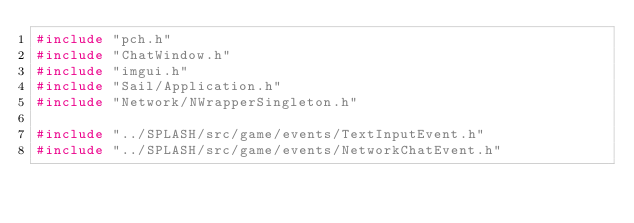Convert code to text. <code><loc_0><loc_0><loc_500><loc_500><_C++_>#include "pch.h"
#include "ChatWindow.h"
#include "imgui.h"
#include "Sail/Application.h"
#include "Network/NWrapperSingleton.h"

#include "../SPLASH/src/game/events/TextInputEvent.h"
#include "../SPLASH/src/game/events/NetworkChatEvent.h"</code> 